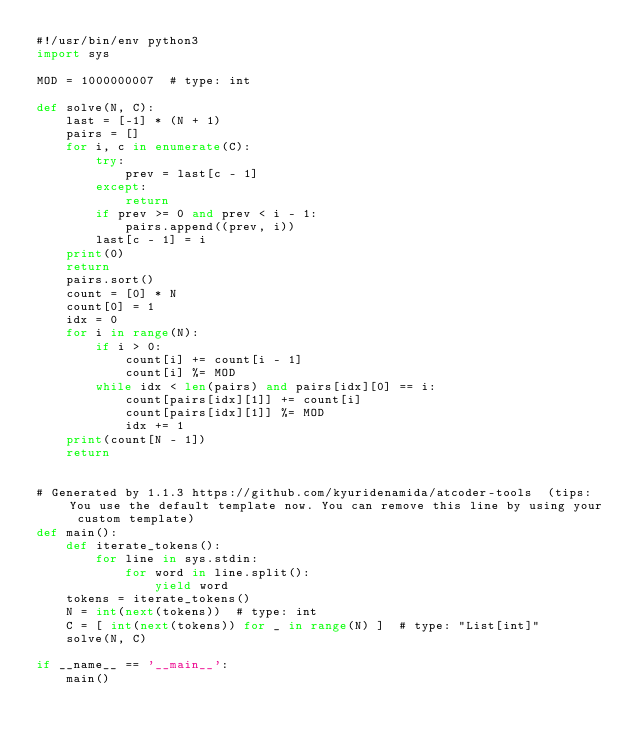Convert code to text. <code><loc_0><loc_0><loc_500><loc_500><_Python_>#!/usr/bin/env python3
import sys

MOD = 1000000007  # type: int

def solve(N, C):
    last = [-1] * (N + 1)
    pairs = []
    for i, c in enumerate(C):
        try:
            prev = last[c - 1]
        except:
            return
        if prev >= 0 and prev < i - 1:
            pairs.append((prev, i))
        last[c - 1] = i
    print(0)
    return
    pairs.sort()
    count = [0] * N
    count[0] = 1
    idx = 0
    for i in range(N):
        if i > 0:
            count[i] += count[i - 1]
            count[i] %= MOD
        while idx < len(pairs) and pairs[idx][0] == i:
            count[pairs[idx][1]] += count[i]
            count[pairs[idx][1]] %= MOD
            idx += 1
    print(count[N - 1])
    return


# Generated by 1.1.3 https://github.com/kyuridenamida/atcoder-tools  (tips: You use the default template now. You can remove this line by using your custom template)
def main():
    def iterate_tokens():
        for line in sys.stdin:
            for word in line.split():
                yield word
    tokens = iterate_tokens()
    N = int(next(tokens))  # type: int
    C = [ int(next(tokens)) for _ in range(N) ]  # type: "List[int]"
    solve(N, C)

if __name__ == '__main__':
    main()
</code> 